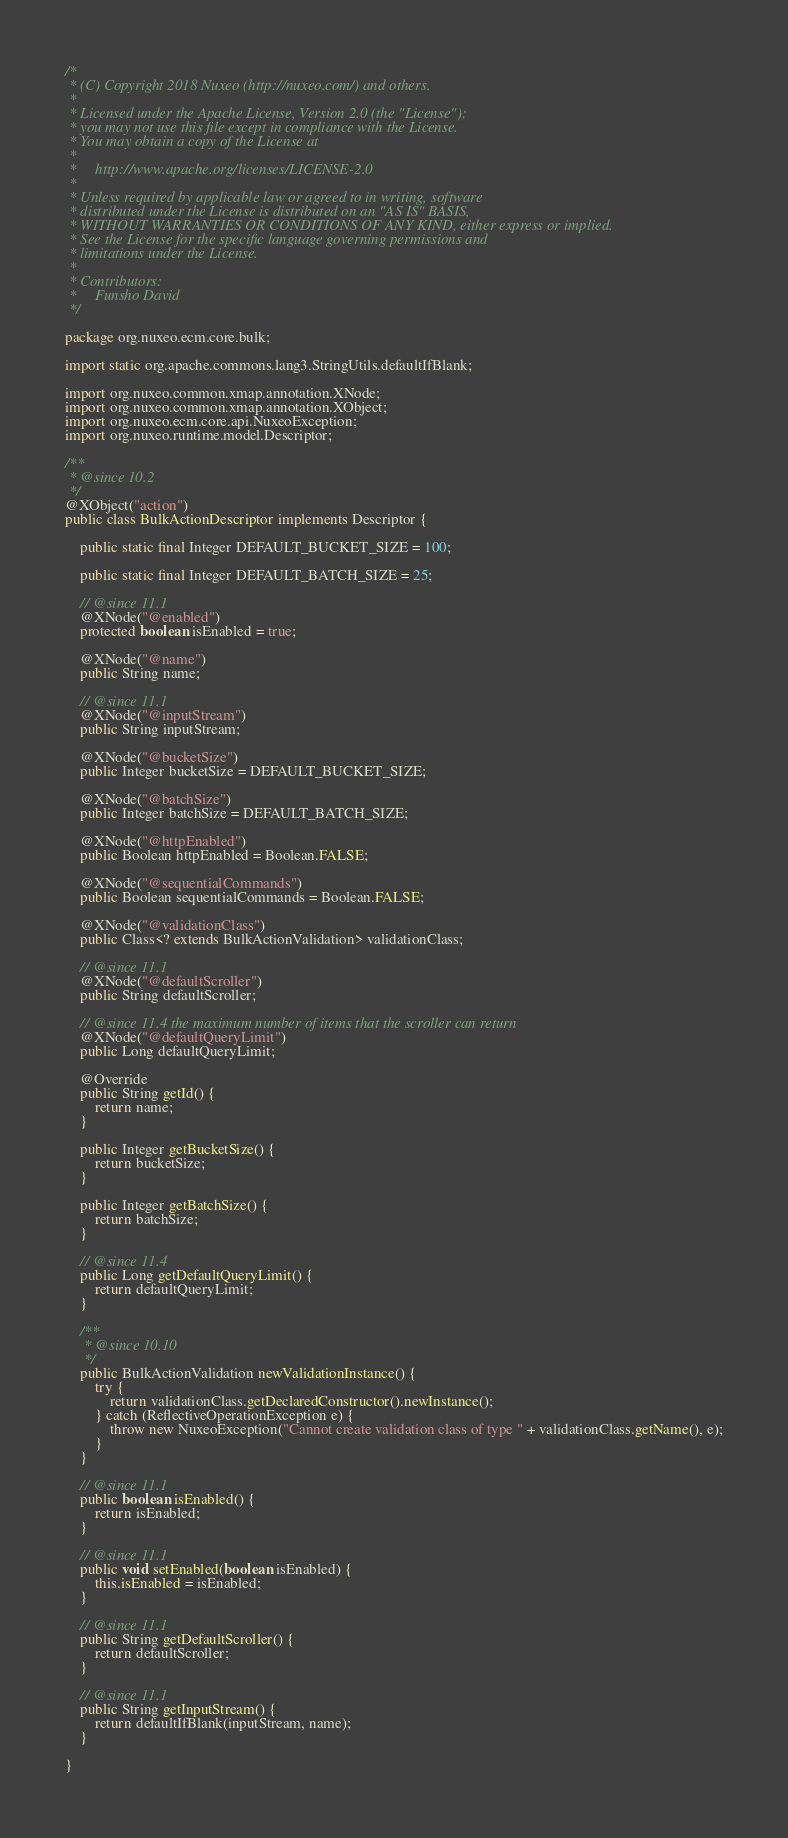Convert code to text. <code><loc_0><loc_0><loc_500><loc_500><_Java_>/*
 * (C) Copyright 2018 Nuxeo (http://nuxeo.com/) and others.
 *
 * Licensed under the Apache License, Version 2.0 (the "License");
 * you may not use this file except in compliance with the License.
 * You may obtain a copy of the License at
 *
 *     http://www.apache.org/licenses/LICENSE-2.0
 *
 * Unless required by applicable law or agreed to in writing, software
 * distributed under the License is distributed on an "AS IS" BASIS,
 * WITHOUT WARRANTIES OR CONDITIONS OF ANY KIND, either express or implied.
 * See the License for the specific language governing permissions and
 * limitations under the License.
 *
 * Contributors:
 *     Funsho David
 */

package org.nuxeo.ecm.core.bulk;

import static org.apache.commons.lang3.StringUtils.defaultIfBlank;

import org.nuxeo.common.xmap.annotation.XNode;
import org.nuxeo.common.xmap.annotation.XObject;
import org.nuxeo.ecm.core.api.NuxeoException;
import org.nuxeo.runtime.model.Descriptor;

/**
 * @since 10.2
 */
@XObject("action")
public class BulkActionDescriptor implements Descriptor {

    public static final Integer DEFAULT_BUCKET_SIZE = 100;

    public static final Integer DEFAULT_BATCH_SIZE = 25;

    // @since 11.1
    @XNode("@enabled")
    protected boolean isEnabled = true;

    @XNode("@name")
    public String name;

    // @since 11.1
    @XNode("@inputStream")
    public String inputStream;

    @XNode("@bucketSize")
    public Integer bucketSize = DEFAULT_BUCKET_SIZE;

    @XNode("@batchSize")
    public Integer batchSize = DEFAULT_BATCH_SIZE;

    @XNode("@httpEnabled")
    public Boolean httpEnabled = Boolean.FALSE;

    @XNode("@sequentialCommands")
    public Boolean sequentialCommands = Boolean.FALSE;

    @XNode("@validationClass")
    public Class<? extends BulkActionValidation> validationClass;

    // @since 11.1
    @XNode("@defaultScroller")
    public String defaultScroller;

    // @since 11.4 the maximum number of items that the scroller can return
    @XNode("@defaultQueryLimit")
    public Long defaultQueryLimit;

    @Override
    public String getId() {
        return name;
    }

    public Integer getBucketSize() {
        return bucketSize;
    }

    public Integer getBatchSize() {
        return batchSize;
    }

    // @since 11.4
    public Long getDefaultQueryLimit() {
        return defaultQueryLimit;
    }

    /**
     * @since 10.10
     */
    public BulkActionValidation newValidationInstance() {
        try {
            return validationClass.getDeclaredConstructor().newInstance();
        } catch (ReflectiveOperationException e) {
            throw new NuxeoException("Cannot create validation class of type " + validationClass.getName(), e);
        }
    }

    // @since 11.1
    public boolean isEnabled() {
        return isEnabled;
    }

    // @since 11.1
    public void setEnabled(boolean isEnabled) {
        this.isEnabled = isEnabled;
    }

    // @since 11.1
    public String getDefaultScroller() {
        return defaultScroller;
    }

    // @since 11.1
    public String getInputStream() {
        return defaultIfBlank(inputStream, name);
    }

}
</code> 